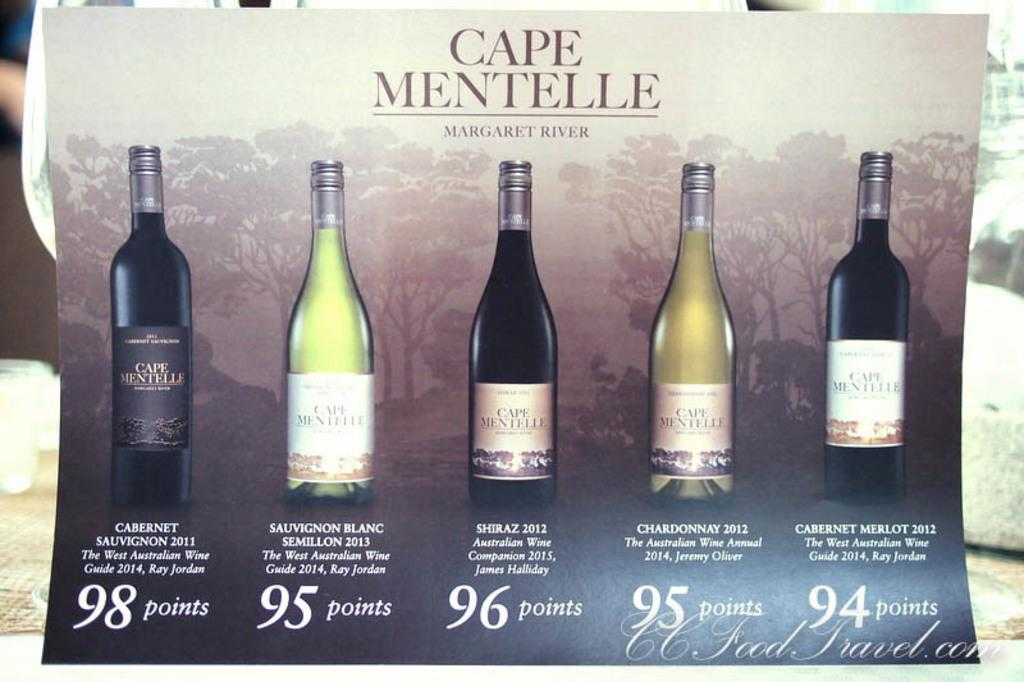<image>
Describe the image concisely. A poster displaying five different bottles of wine from Cape Mentelle has a brief description under each one as well as a point value. 